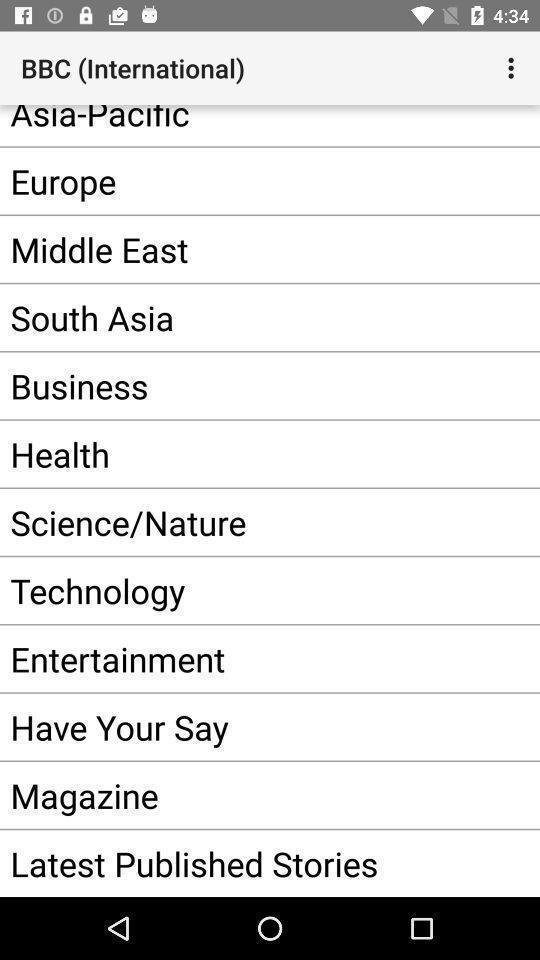What is the overall content of this screenshot? Screen showing topics in an news application. 